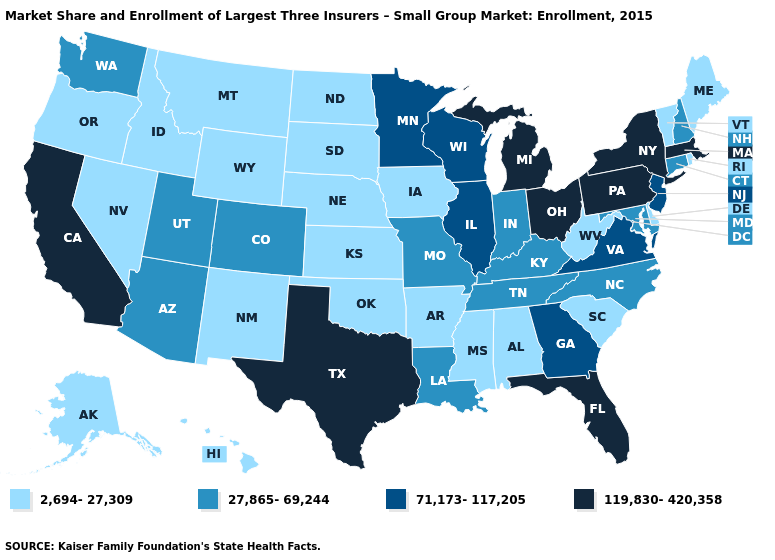What is the value of Nevada?
Answer briefly. 2,694-27,309. What is the highest value in the USA?
Write a very short answer. 119,830-420,358. Name the states that have a value in the range 71,173-117,205?
Answer briefly. Georgia, Illinois, Minnesota, New Jersey, Virginia, Wisconsin. Name the states that have a value in the range 2,694-27,309?
Write a very short answer. Alabama, Alaska, Arkansas, Delaware, Hawaii, Idaho, Iowa, Kansas, Maine, Mississippi, Montana, Nebraska, Nevada, New Mexico, North Dakota, Oklahoma, Oregon, Rhode Island, South Carolina, South Dakota, Vermont, West Virginia, Wyoming. What is the highest value in states that border Minnesota?
Short answer required. 71,173-117,205. Among the states that border Oklahoma , does Colorado have the lowest value?
Answer briefly. No. Name the states that have a value in the range 119,830-420,358?
Concise answer only. California, Florida, Massachusetts, Michigan, New York, Ohio, Pennsylvania, Texas. Which states have the lowest value in the West?
Write a very short answer. Alaska, Hawaii, Idaho, Montana, Nevada, New Mexico, Oregon, Wyoming. What is the value of Hawaii?
Keep it brief. 2,694-27,309. What is the value of Arkansas?
Keep it brief. 2,694-27,309. Name the states that have a value in the range 2,694-27,309?
Quick response, please. Alabama, Alaska, Arkansas, Delaware, Hawaii, Idaho, Iowa, Kansas, Maine, Mississippi, Montana, Nebraska, Nevada, New Mexico, North Dakota, Oklahoma, Oregon, Rhode Island, South Carolina, South Dakota, Vermont, West Virginia, Wyoming. What is the value of Washington?
Quick response, please. 27,865-69,244. Among the states that border Colorado , which have the highest value?
Write a very short answer. Arizona, Utah. Does the map have missing data?
Short answer required. No. Does the map have missing data?
Answer briefly. No. 